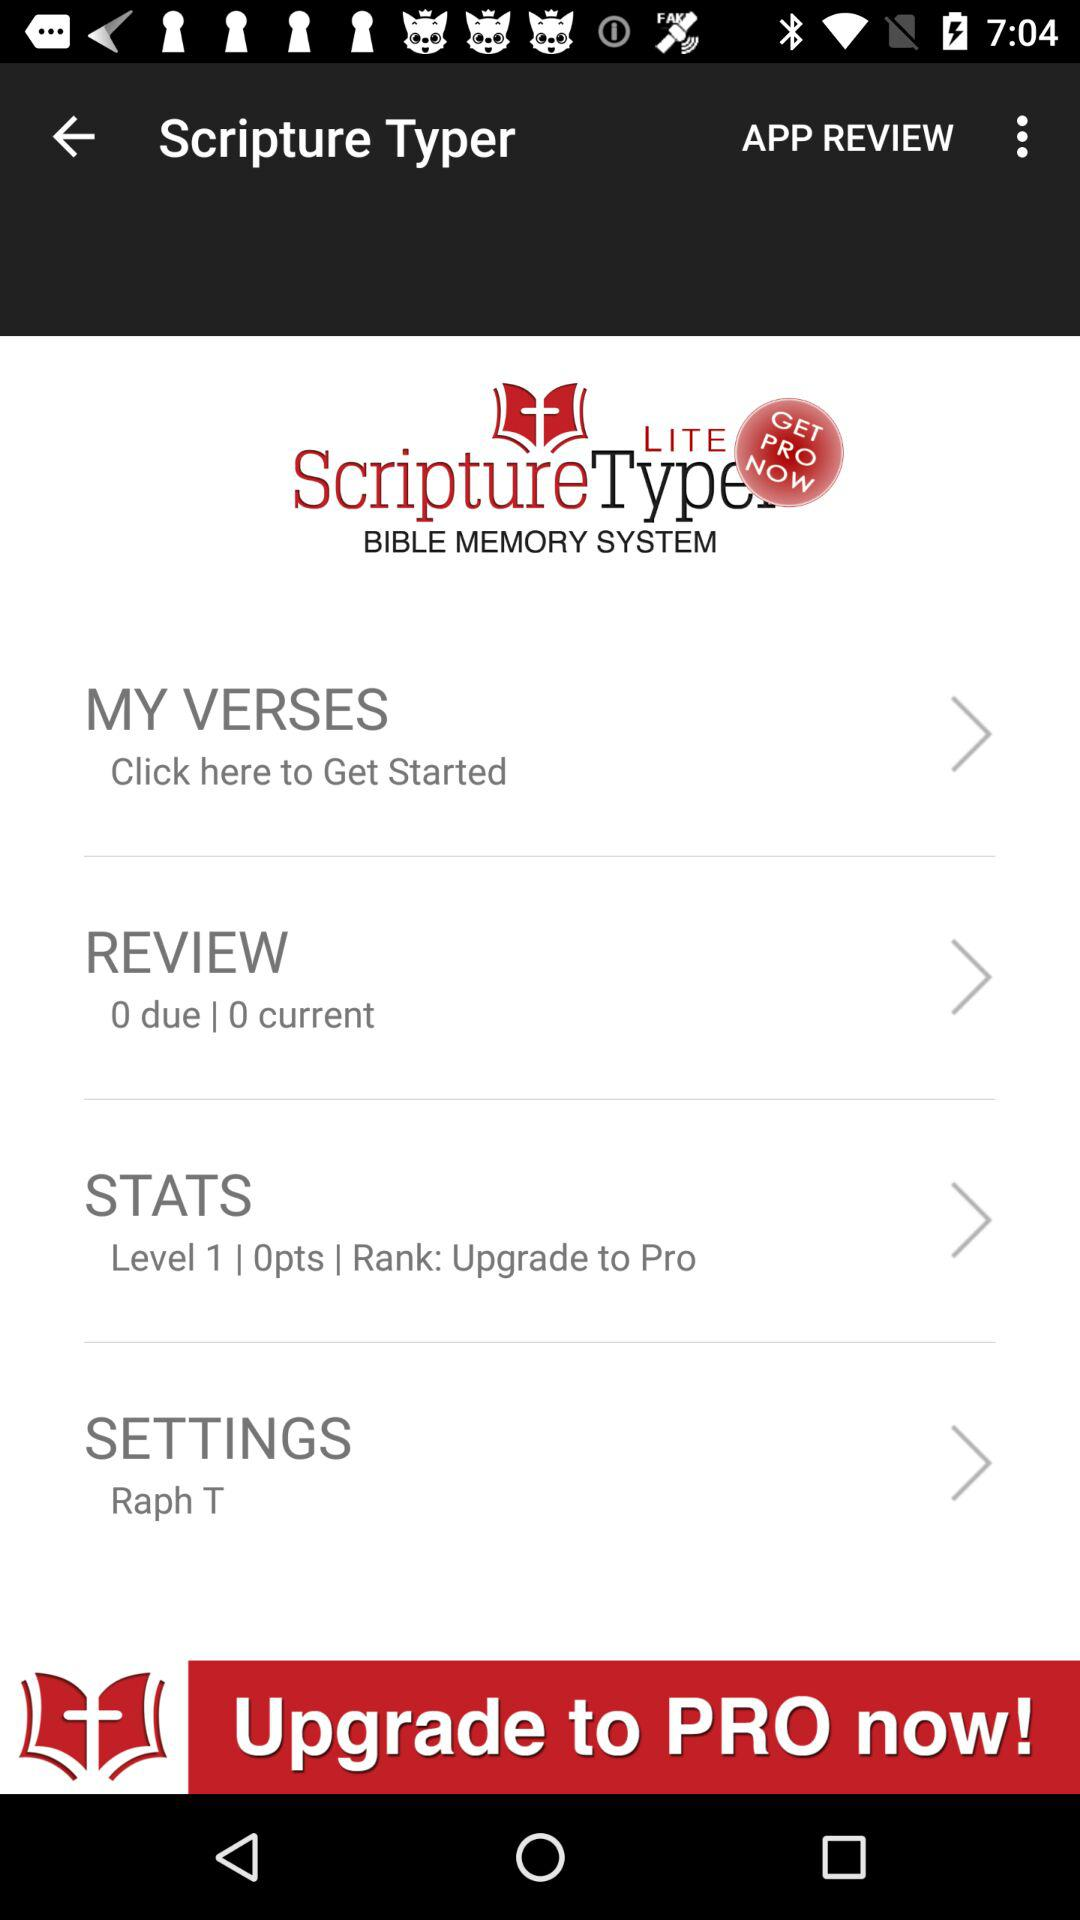What is the count of current review?
When the provided information is insufficient, respond with <no answer>. <no answer> 